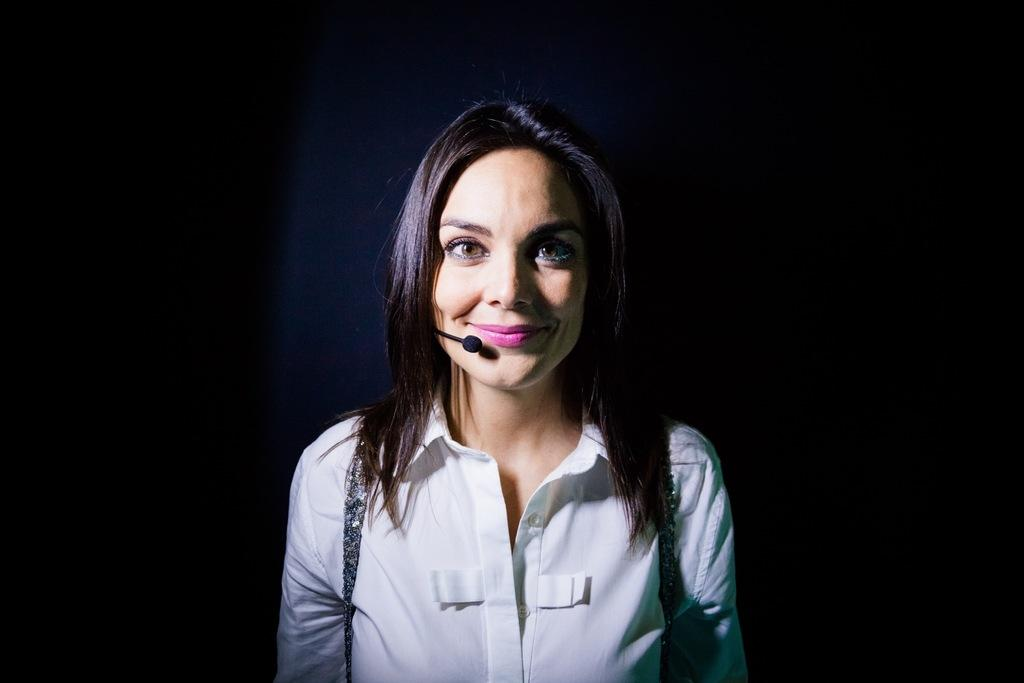Who is the main subject in the image? There is a woman in the image. What is the woman doing in the image? The woman is standing. What color is the shirt the woman is wearing? The woman is wearing a white color shirt. What can be observed about the background of the image? The background of the image is dark. What type of bone is visible in the woman's hand in the image? There is no bone visible in the woman's hand in the image. What board game is the woman playing with her parent in the image? There is no board game or parent present in the image. 